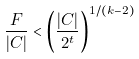<formula> <loc_0><loc_0><loc_500><loc_500>\frac { F } { | C | } < \left ( \frac { | C | } { 2 ^ { t } } \right ) ^ { 1 / ( k - 2 ) }</formula> 